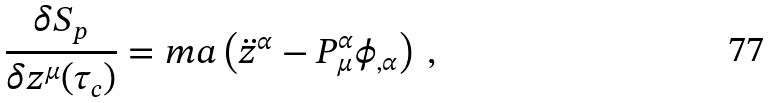<formula> <loc_0><loc_0><loc_500><loc_500>\frac { \delta S _ { p } } { \delta z ^ { \mu } ( \tau _ { c } ) } = m a \left ( \ddot { z } ^ { \alpha } - P ^ { \alpha } _ { \mu } \phi _ { , \alpha } \right ) \, ,</formula> 